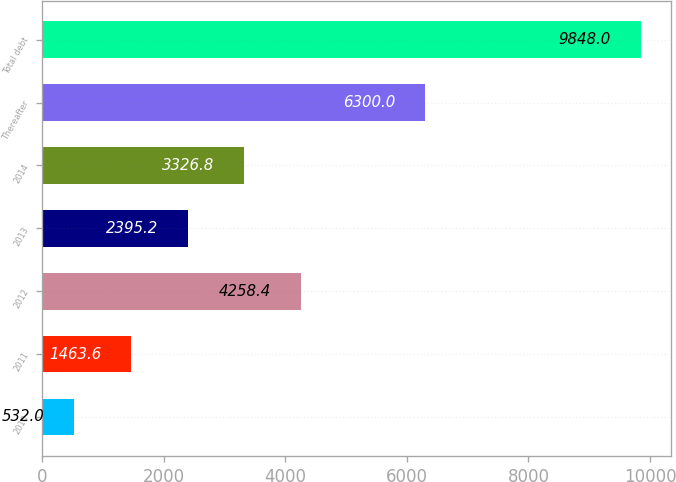<chart> <loc_0><loc_0><loc_500><loc_500><bar_chart><fcel>2010<fcel>2011<fcel>2012<fcel>2013<fcel>2014<fcel>Thereafter<fcel>Total debt<nl><fcel>532<fcel>1463.6<fcel>4258.4<fcel>2395.2<fcel>3326.8<fcel>6300<fcel>9848<nl></chart> 